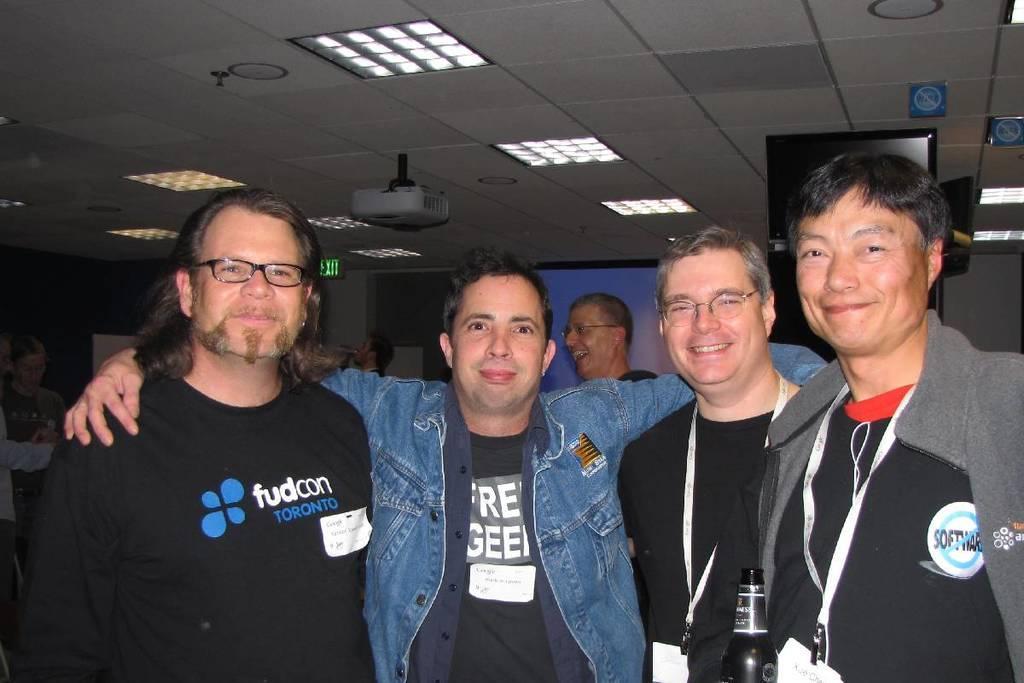How would you summarize this image in a sentence or two? This is an inside view of a room. Here I can see four men standing, smiling and giving pose for the picture. At the back there are some more people. In the background there is a screen and also I can see the wall. At the top of the image there are few lights to the roof. 